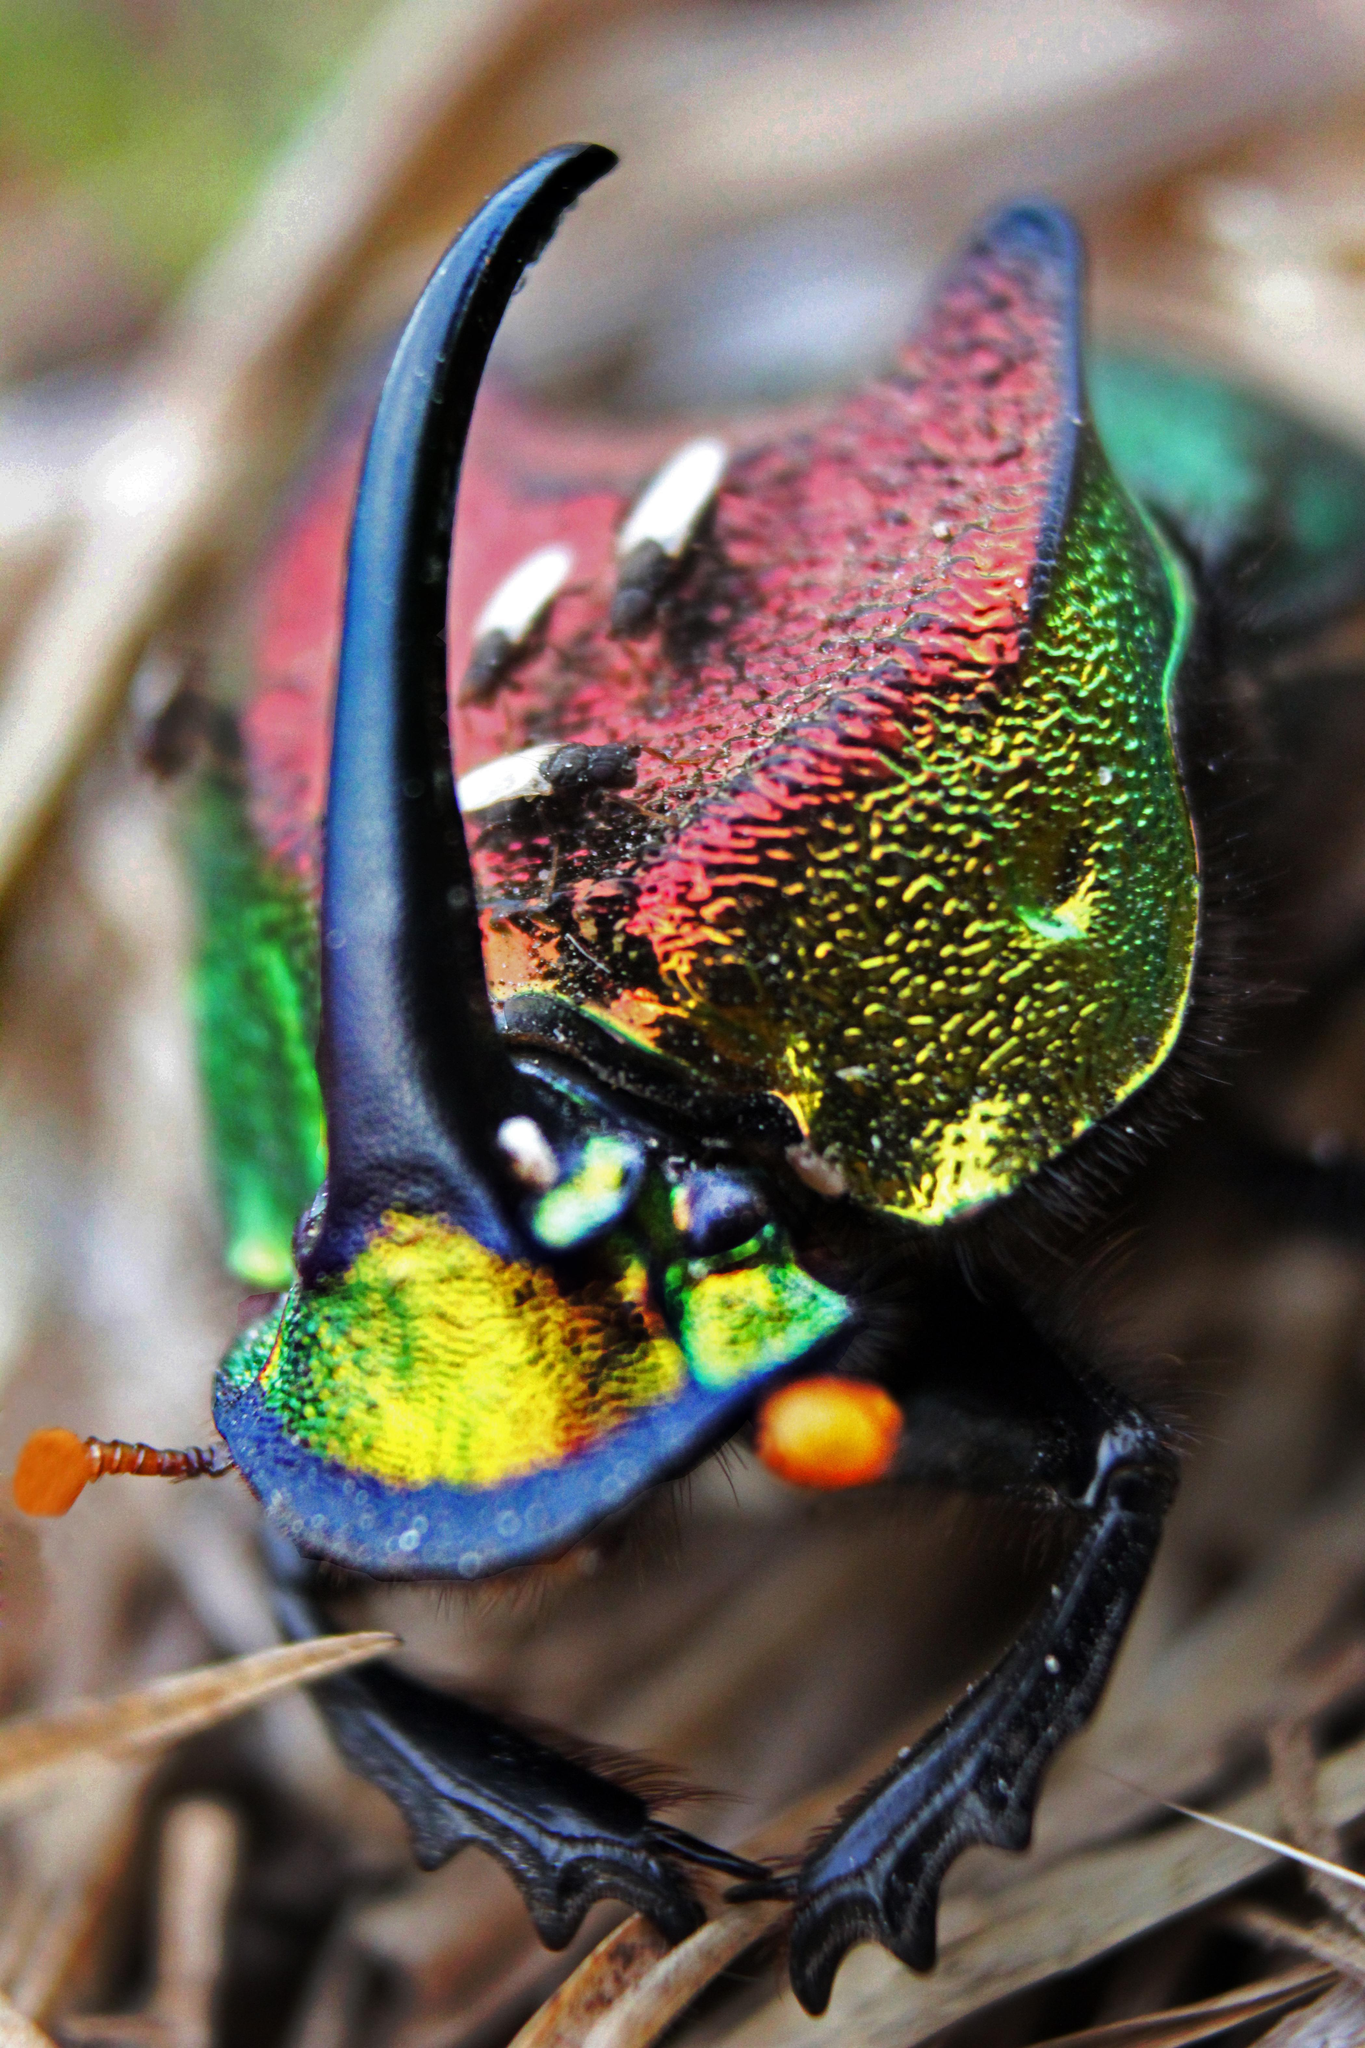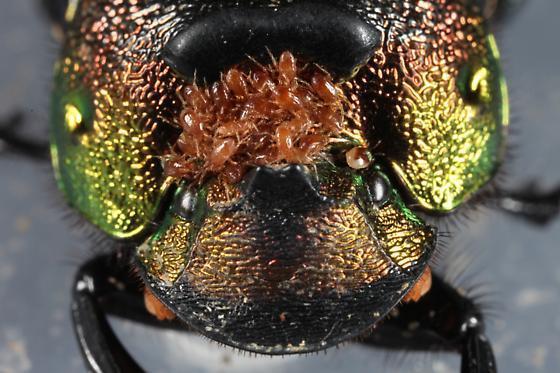The first image is the image on the left, the second image is the image on the right. For the images displayed, is the sentence "At least one image shows a beetle with a large horn." factually correct? Answer yes or no. Yes. 